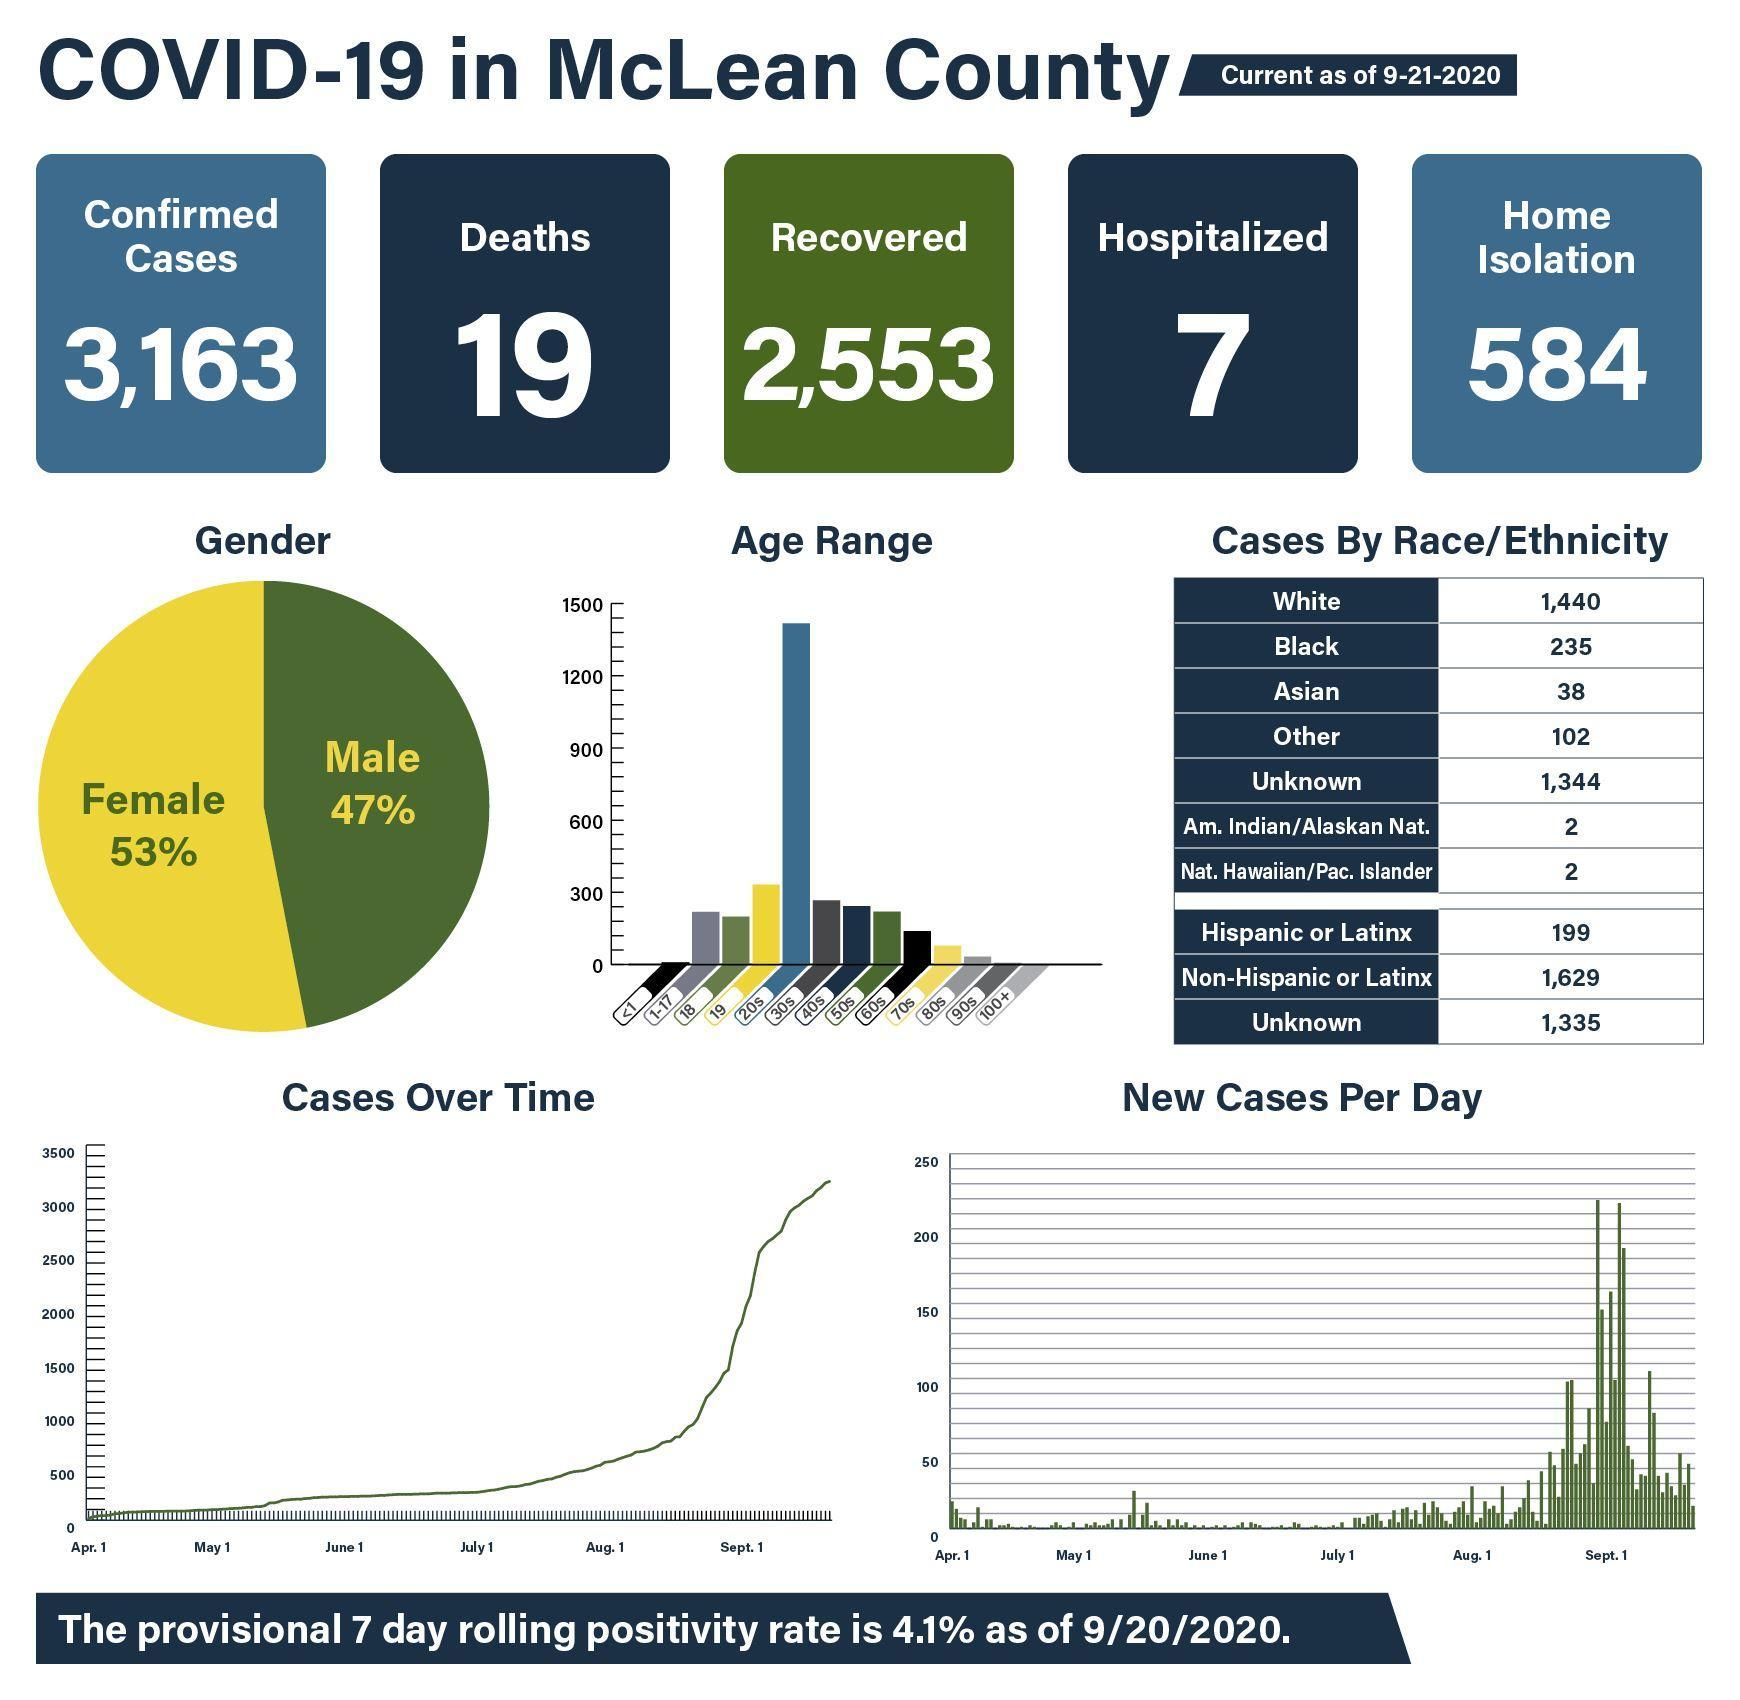How many age groups have the number of cases equal to greater than 300?
Answer the question with a short phrase. 2 How many confirmed cases? 3163 How many races has the number of cases equals to 2? 2 Which race has the highest number of cases? Non-Hispanic or Latinx Which one has the highest share-female, male? female Which all age groups have the number of cases equal to greater than 300? 19, 20s What is the number of recovered cases? 2,553 